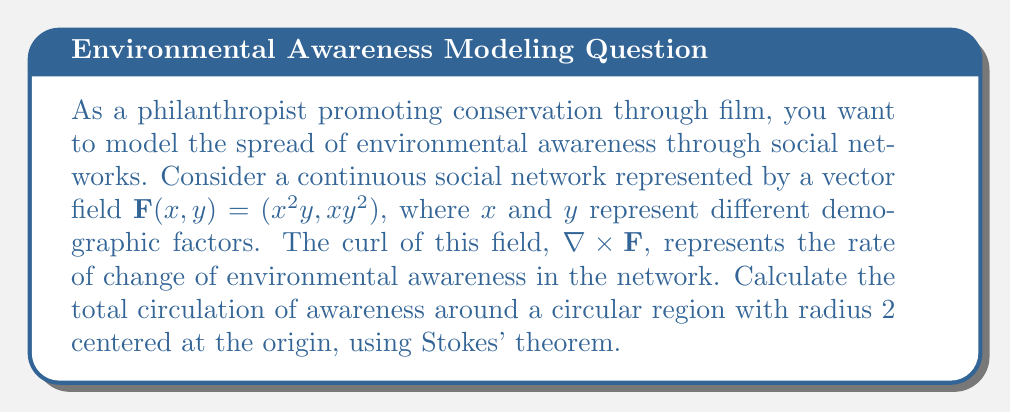Show me your answer to this math problem. To solve this problem, we'll follow these steps:

1) First, we need to calculate the curl of the vector field $\mathbf{F}(x, y) = (x^2y, xy^2)$:

   $\nabla \times \mathbf{F} = \frac{\partial}{\partial x}(xy^2) - \frac{\partial}{\partial y}(x^2y) = y^2 - x^2$

2) According to Stokes' theorem:

   $$\oint_C \mathbf{F} \cdot d\mathbf{r} = \iint_S (\nabla \times \mathbf{F}) \cdot d\mathbf{S}$$

   where $C$ is the boundary of the surface $S$.

3) In our case, $S$ is a circular region with radius 2. We can parameterize this in polar coordinates:

   $x = r\cos\theta$, $y = r\sin\theta$, $0 \leq r \leq 2$, $0 \leq \theta \leq 2\pi$

4) The surface element in polar coordinates is:

   $d\mathbf{S} = rdrd\theta \hat{k}$

5) Now we can set up our double integral:

   $$\iint_S (\nabla \times \mathbf{F}) \cdot d\mathbf{S} = \int_0^{2\pi} \int_0^2 (r^2\sin^2\theta - r^2\cos^2\theta) rdrd\theta$$

6) Simplify the integrand:

   $r^2\sin^2\theta - r^2\cos^2\theta = r^2(\sin^2\theta - \cos^2\theta) = -r^2\cos(2\theta)$

7) Our integral becomes:

   $$\int_0^{2\pi} \int_0^2 -r^3\cos(2\theta) drd\theta$$

8) Integrate with respect to $r$:

   $$\int_0^{2\pi} [-\frac{r^4}{4}\cos(2\theta)]_0^2 d\theta = -4\int_0^{2\pi} \cos(2\theta) d\theta$$

9) Integrate with respect to $\theta$:

   $$-4[\frac{1}{2}\sin(2\theta)]_0^{2\pi} = 0$$

Therefore, the total circulation of awareness around the circular region is 0.
Answer: 0 